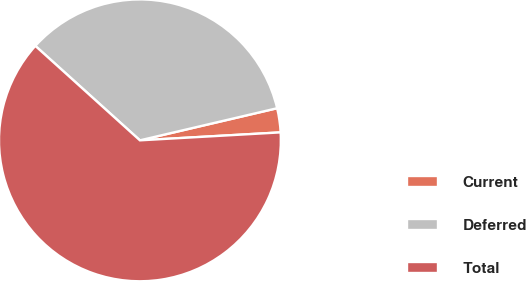Convert chart to OTSL. <chart><loc_0><loc_0><loc_500><loc_500><pie_chart><fcel>Current<fcel>Deferred<fcel>Total<nl><fcel>2.76%<fcel>34.65%<fcel>62.59%<nl></chart> 